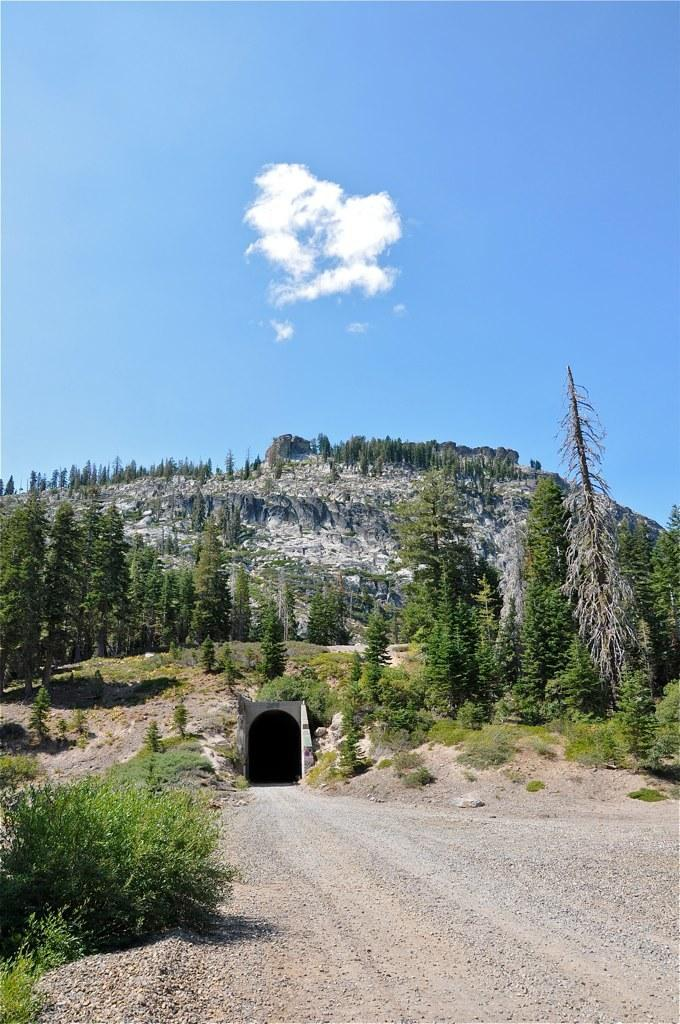What type of natural elements can be seen in the image? There are trees and plants in the image. What type of geographical feature is visible in the image? There are mountains in the image. How is the road connected in the image? The road is connected to a subway in the image. What is the condition of the sky in the image? The sky is cloudy in the image. What color is the silver frog that can be seen touching the trees in the image? There is no silver frog present in the image, nor is there any indication of a frog touching the trees. 